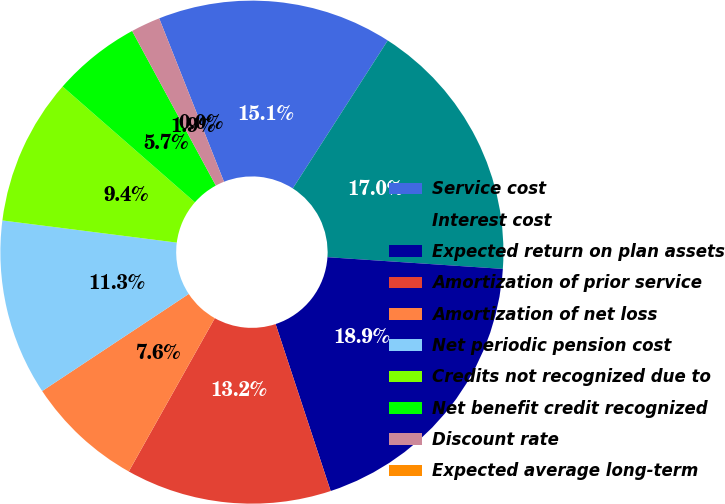Convert chart to OTSL. <chart><loc_0><loc_0><loc_500><loc_500><pie_chart><fcel>Service cost<fcel>Interest cost<fcel>Expected return on plan assets<fcel>Amortization of prior service<fcel>Amortization of net loss<fcel>Net periodic pension cost<fcel>Credits not recognized due to<fcel>Net benefit credit recognized<fcel>Discount rate<fcel>Expected average long-term<nl><fcel>15.09%<fcel>16.98%<fcel>18.87%<fcel>13.21%<fcel>7.55%<fcel>11.32%<fcel>9.43%<fcel>5.66%<fcel>1.89%<fcel>0.0%<nl></chart> 